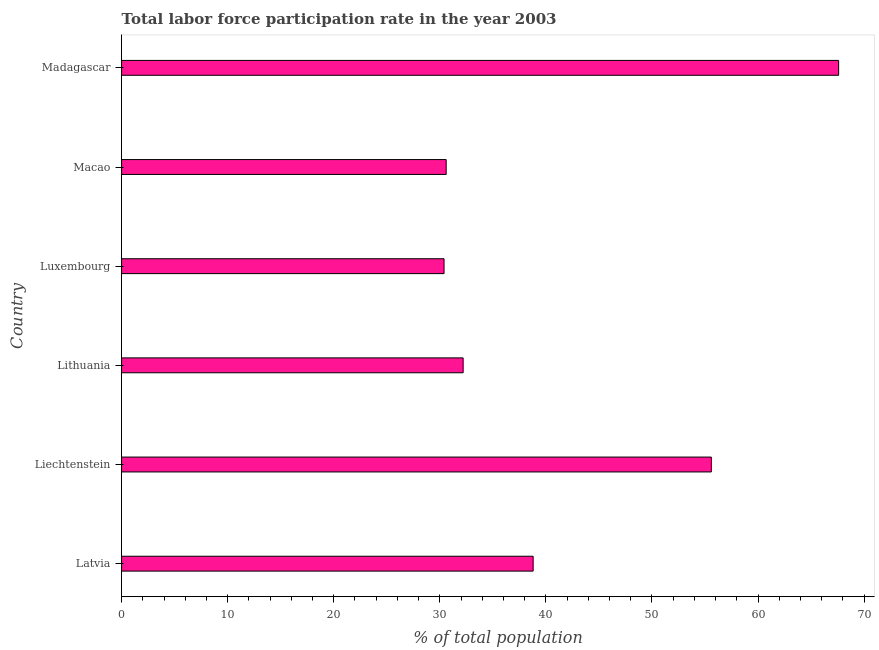Does the graph contain any zero values?
Your answer should be compact. No. Does the graph contain grids?
Your answer should be very brief. No. What is the title of the graph?
Give a very brief answer. Total labor force participation rate in the year 2003. What is the label or title of the X-axis?
Offer a terse response. % of total population. What is the total labor force participation rate in Macao?
Offer a very short reply. 30.6. Across all countries, what is the maximum total labor force participation rate?
Provide a short and direct response. 67.6. Across all countries, what is the minimum total labor force participation rate?
Provide a succinct answer. 30.4. In which country was the total labor force participation rate maximum?
Make the answer very short. Madagascar. In which country was the total labor force participation rate minimum?
Your answer should be compact. Luxembourg. What is the sum of the total labor force participation rate?
Offer a very short reply. 255.2. What is the difference between the total labor force participation rate in Latvia and Madagascar?
Your response must be concise. -28.8. What is the average total labor force participation rate per country?
Offer a very short reply. 42.53. What is the median total labor force participation rate?
Your response must be concise. 35.5. In how many countries, is the total labor force participation rate greater than 6 %?
Your answer should be compact. 6. What is the ratio of the total labor force participation rate in Lithuania to that in Luxembourg?
Keep it short and to the point. 1.06. What is the difference between the highest and the second highest total labor force participation rate?
Give a very brief answer. 12. What is the difference between the highest and the lowest total labor force participation rate?
Offer a very short reply. 37.2. In how many countries, is the total labor force participation rate greater than the average total labor force participation rate taken over all countries?
Keep it short and to the point. 2. Are all the bars in the graph horizontal?
Make the answer very short. Yes. How many countries are there in the graph?
Ensure brevity in your answer.  6. What is the difference between two consecutive major ticks on the X-axis?
Offer a very short reply. 10. What is the % of total population of Latvia?
Give a very brief answer. 38.8. What is the % of total population of Liechtenstein?
Offer a terse response. 55.6. What is the % of total population in Lithuania?
Provide a short and direct response. 32.2. What is the % of total population in Luxembourg?
Your answer should be compact. 30.4. What is the % of total population in Macao?
Offer a very short reply. 30.6. What is the % of total population in Madagascar?
Make the answer very short. 67.6. What is the difference between the % of total population in Latvia and Liechtenstein?
Make the answer very short. -16.8. What is the difference between the % of total population in Latvia and Lithuania?
Offer a terse response. 6.6. What is the difference between the % of total population in Latvia and Macao?
Ensure brevity in your answer.  8.2. What is the difference between the % of total population in Latvia and Madagascar?
Offer a terse response. -28.8. What is the difference between the % of total population in Liechtenstein and Lithuania?
Provide a short and direct response. 23.4. What is the difference between the % of total population in Liechtenstein and Luxembourg?
Offer a terse response. 25.2. What is the difference between the % of total population in Liechtenstein and Madagascar?
Offer a very short reply. -12. What is the difference between the % of total population in Lithuania and Macao?
Your response must be concise. 1.6. What is the difference between the % of total population in Lithuania and Madagascar?
Give a very brief answer. -35.4. What is the difference between the % of total population in Luxembourg and Madagascar?
Offer a very short reply. -37.2. What is the difference between the % of total population in Macao and Madagascar?
Keep it short and to the point. -37. What is the ratio of the % of total population in Latvia to that in Liechtenstein?
Offer a terse response. 0.7. What is the ratio of the % of total population in Latvia to that in Lithuania?
Provide a succinct answer. 1.21. What is the ratio of the % of total population in Latvia to that in Luxembourg?
Offer a terse response. 1.28. What is the ratio of the % of total population in Latvia to that in Macao?
Offer a terse response. 1.27. What is the ratio of the % of total population in Latvia to that in Madagascar?
Your answer should be compact. 0.57. What is the ratio of the % of total population in Liechtenstein to that in Lithuania?
Keep it short and to the point. 1.73. What is the ratio of the % of total population in Liechtenstein to that in Luxembourg?
Provide a succinct answer. 1.83. What is the ratio of the % of total population in Liechtenstein to that in Macao?
Your answer should be very brief. 1.82. What is the ratio of the % of total population in Liechtenstein to that in Madagascar?
Your answer should be very brief. 0.82. What is the ratio of the % of total population in Lithuania to that in Luxembourg?
Provide a short and direct response. 1.06. What is the ratio of the % of total population in Lithuania to that in Macao?
Offer a very short reply. 1.05. What is the ratio of the % of total population in Lithuania to that in Madagascar?
Your answer should be very brief. 0.48. What is the ratio of the % of total population in Luxembourg to that in Macao?
Ensure brevity in your answer.  0.99. What is the ratio of the % of total population in Luxembourg to that in Madagascar?
Your answer should be very brief. 0.45. What is the ratio of the % of total population in Macao to that in Madagascar?
Keep it short and to the point. 0.45. 